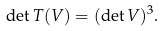Convert formula to latex. <formula><loc_0><loc_0><loc_500><loc_500>\det T ( V ) = ( \det V ) ^ { 3 } .</formula> 